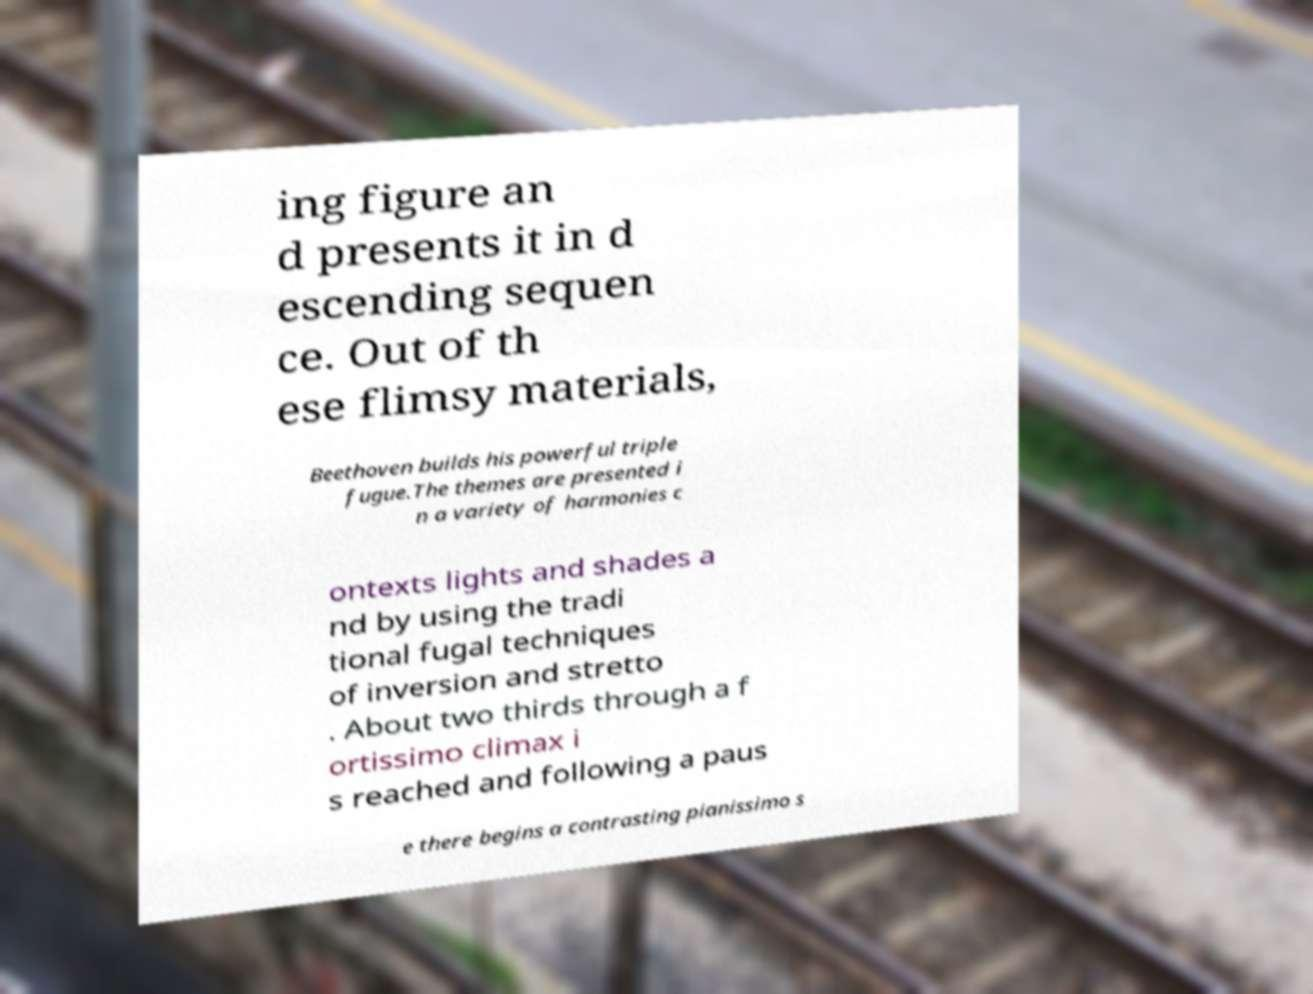Please identify and transcribe the text found in this image. ing figure an d presents it in d escending sequen ce. Out of th ese flimsy materials, Beethoven builds his powerful triple fugue.The themes are presented i n a variety of harmonies c ontexts lights and shades a nd by using the tradi tional fugal techniques of inversion and stretto . About two thirds through a f ortissimo climax i s reached and following a paus e there begins a contrasting pianissimo s 